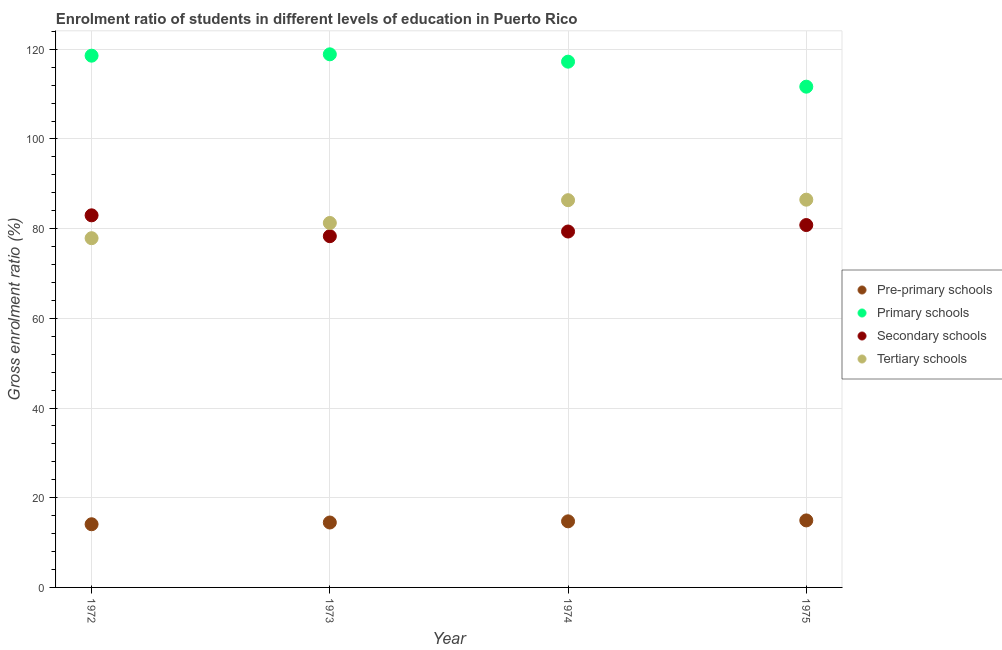How many different coloured dotlines are there?
Offer a terse response. 4. What is the gross enrolment ratio in tertiary schools in 1975?
Keep it short and to the point. 86.46. Across all years, what is the maximum gross enrolment ratio in secondary schools?
Offer a terse response. 82.97. Across all years, what is the minimum gross enrolment ratio in tertiary schools?
Make the answer very short. 77.87. In which year was the gross enrolment ratio in primary schools minimum?
Keep it short and to the point. 1975. What is the total gross enrolment ratio in pre-primary schools in the graph?
Ensure brevity in your answer.  58.24. What is the difference between the gross enrolment ratio in pre-primary schools in 1973 and that in 1975?
Provide a short and direct response. -0.46. What is the difference between the gross enrolment ratio in tertiary schools in 1972 and the gross enrolment ratio in secondary schools in 1973?
Your response must be concise. -0.45. What is the average gross enrolment ratio in tertiary schools per year?
Your response must be concise. 82.99. In the year 1975, what is the difference between the gross enrolment ratio in secondary schools and gross enrolment ratio in tertiary schools?
Ensure brevity in your answer.  -5.66. In how many years, is the gross enrolment ratio in tertiary schools greater than 84 %?
Offer a very short reply. 2. What is the ratio of the gross enrolment ratio in primary schools in 1973 to that in 1975?
Make the answer very short. 1.06. Is the gross enrolment ratio in secondary schools in 1973 less than that in 1974?
Your answer should be very brief. Yes. What is the difference between the highest and the second highest gross enrolment ratio in pre-primary schools?
Keep it short and to the point. 0.21. What is the difference between the highest and the lowest gross enrolment ratio in primary schools?
Keep it short and to the point. 7.21. Is it the case that in every year, the sum of the gross enrolment ratio in primary schools and gross enrolment ratio in tertiary schools is greater than the sum of gross enrolment ratio in pre-primary schools and gross enrolment ratio in secondary schools?
Make the answer very short. Yes. Is it the case that in every year, the sum of the gross enrolment ratio in pre-primary schools and gross enrolment ratio in primary schools is greater than the gross enrolment ratio in secondary schools?
Offer a terse response. Yes. Does the gross enrolment ratio in tertiary schools monotonically increase over the years?
Your answer should be very brief. Yes. Is the gross enrolment ratio in primary schools strictly less than the gross enrolment ratio in pre-primary schools over the years?
Provide a succinct answer. No. How many dotlines are there?
Make the answer very short. 4. How many years are there in the graph?
Your answer should be compact. 4. Are the values on the major ticks of Y-axis written in scientific E-notation?
Keep it short and to the point. No. Where does the legend appear in the graph?
Your answer should be compact. Center right. What is the title of the graph?
Give a very brief answer. Enrolment ratio of students in different levels of education in Puerto Rico. What is the label or title of the X-axis?
Give a very brief answer. Year. What is the label or title of the Y-axis?
Provide a succinct answer. Gross enrolment ratio (%). What is the Gross enrolment ratio (%) in Pre-primary schools in 1972?
Your answer should be very brief. 14.09. What is the Gross enrolment ratio (%) in Primary schools in 1972?
Your response must be concise. 118.57. What is the Gross enrolment ratio (%) in Secondary schools in 1972?
Offer a terse response. 82.97. What is the Gross enrolment ratio (%) of Tertiary schools in 1972?
Give a very brief answer. 77.87. What is the Gross enrolment ratio (%) in Pre-primary schools in 1973?
Keep it short and to the point. 14.48. What is the Gross enrolment ratio (%) of Primary schools in 1973?
Provide a short and direct response. 118.87. What is the Gross enrolment ratio (%) of Secondary schools in 1973?
Your answer should be very brief. 78.32. What is the Gross enrolment ratio (%) in Tertiary schools in 1973?
Provide a short and direct response. 81.26. What is the Gross enrolment ratio (%) of Pre-primary schools in 1974?
Provide a short and direct response. 14.74. What is the Gross enrolment ratio (%) in Primary schools in 1974?
Give a very brief answer. 117.23. What is the Gross enrolment ratio (%) in Secondary schools in 1974?
Offer a very short reply. 79.36. What is the Gross enrolment ratio (%) of Tertiary schools in 1974?
Ensure brevity in your answer.  86.35. What is the Gross enrolment ratio (%) of Pre-primary schools in 1975?
Your answer should be compact. 14.94. What is the Gross enrolment ratio (%) in Primary schools in 1975?
Offer a terse response. 111.66. What is the Gross enrolment ratio (%) in Secondary schools in 1975?
Keep it short and to the point. 80.8. What is the Gross enrolment ratio (%) in Tertiary schools in 1975?
Ensure brevity in your answer.  86.46. Across all years, what is the maximum Gross enrolment ratio (%) in Pre-primary schools?
Your response must be concise. 14.94. Across all years, what is the maximum Gross enrolment ratio (%) of Primary schools?
Give a very brief answer. 118.87. Across all years, what is the maximum Gross enrolment ratio (%) in Secondary schools?
Provide a short and direct response. 82.97. Across all years, what is the maximum Gross enrolment ratio (%) in Tertiary schools?
Your answer should be very brief. 86.46. Across all years, what is the minimum Gross enrolment ratio (%) in Pre-primary schools?
Provide a succinct answer. 14.09. Across all years, what is the minimum Gross enrolment ratio (%) in Primary schools?
Your answer should be very brief. 111.66. Across all years, what is the minimum Gross enrolment ratio (%) of Secondary schools?
Your answer should be compact. 78.32. Across all years, what is the minimum Gross enrolment ratio (%) in Tertiary schools?
Give a very brief answer. 77.87. What is the total Gross enrolment ratio (%) of Pre-primary schools in the graph?
Your answer should be compact. 58.24. What is the total Gross enrolment ratio (%) in Primary schools in the graph?
Make the answer very short. 466.33. What is the total Gross enrolment ratio (%) in Secondary schools in the graph?
Offer a very short reply. 321.45. What is the total Gross enrolment ratio (%) of Tertiary schools in the graph?
Ensure brevity in your answer.  331.94. What is the difference between the Gross enrolment ratio (%) of Pre-primary schools in 1972 and that in 1973?
Offer a very short reply. -0.39. What is the difference between the Gross enrolment ratio (%) of Primary schools in 1972 and that in 1973?
Your answer should be very brief. -0.3. What is the difference between the Gross enrolment ratio (%) in Secondary schools in 1972 and that in 1973?
Provide a succinct answer. 4.65. What is the difference between the Gross enrolment ratio (%) of Tertiary schools in 1972 and that in 1973?
Your answer should be compact. -3.39. What is the difference between the Gross enrolment ratio (%) in Pre-primary schools in 1972 and that in 1974?
Provide a succinct answer. -0.65. What is the difference between the Gross enrolment ratio (%) of Primary schools in 1972 and that in 1974?
Make the answer very short. 1.33. What is the difference between the Gross enrolment ratio (%) of Secondary schools in 1972 and that in 1974?
Offer a terse response. 3.61. What is the difference between the Gross enrolment ratio (%) in Tertiary schools in 1972 and that in 1974?
Give a very brief answer. -8.48. What is the difference between the Gross enrolment ratio (%) of Pre-primary schools in 1972 and that in 1975?
Offer a very short reply. -0.86. What is the difference between the Gross enrolment ratio (%) of Primary schools in 1972 and that in 1975?
Offer a terse response. 6.91. What is the difference between the Gross enrolment ratio (%) in Secondary schools in 1972 and that in 1975?
Your answer should be very brief. 2.17. What is the difference between the Gross enrolment ratio (%) of Tertiary schools in 1972 and that in 1975?
Offer a very short reply. -8.59. What is the difference between the Gross enrolment ratio (%) in Pre-primary schools in 1973 and that in 1974?
Your answer should be very brief. -0.26. What is the difference between the Gross enrolment ratio (%) in Primary schools in 1973 and that in 1974?
Offer a very short reply. 1.64. What is the difference between the Gross enrolment ratio (%) of Secondary schools in 1973 and that in 1974?
Your answer should be very brief. -1.04. What is the difference between the Gross enrolment ratio (%) in Tertiary schools in 1973 and that in 1974?
Give a very brief answer. -5.08. What is the difference between the Gross enrolment ratio (%) of Pre-primary schools in 1973 and that in 1975?
Make the answer very short. -0.46. What is the difference between the Gross enrolment ratio (%) in Primary schools in 1973 and that in 1975?
Ensure brevity in your answer.  7.21. What is the difference between the Gross enrolment ratio (%) in Secondary schools in 1973 and that in 1975?
Offer a very short reply. -2.48. What is the difference between the Gross enrolment ratio (%) in Tertiary schools in 1973 and that in 1975?
Your answer should be compact. -5.2. What is the difference between the Gross enrolment ratio (%) of Pre-primary schools in 1974 and that in 1975?
Make the answer very short. -0.21. What is the difference between the Gross enrolment ratio (%) of Primary schools in 1974 and that in 1975?
Your response must be concise. 5.58. What is the difference between the Gross enrolment ratio (%) of Secondary schools in 1974 and that in 1975?
Your answer should be compact. -1.44. What is the difference between the Gross enrolment ratio (%) of Tertiary schools in 1974 and that in 1975?
Make the answer very short. -0.11. What is the difference between the Gross enrolment ratio (%) of Pre-primary schools in 1972 and the Gross enrolment ratio (%) of Primary schools in 1973?
Make the answer very short. -104.78. What is the difference between the Gross enrolment ratio (%) of Pre-primary schools in 1972 and the Gross enrolment ratio (%) of Secondary schools in 1973?
Provide a succinct answer. -64.23. What is the difference between the Gross enrolment ratio (%) in Pre-primary schools in 1972 and the Gross enrolment ratio (%) in Tertiary schools in 1973?
Ensure brevity in your answer.  -67.18. What is the difference between the Gross enrolment ratio (%) of Primary schools in 1972 and the Gross enrolment ratio (%) of Secondary schools in 1973?
Your answer should be compact. 40.25. What is the difference between the Gross enrolment ratio (%) in Primary schools in 1972 and the Gross enrolment ratio (%) in Tertiary schools in 1973?
Provide a short and direct response. 37.3. What is the difference between the Gross enrolment ratio (%) in Secondary schools in 1972 and the Gross enrolment ratio (%) in Tertiary schools in 1973?
Keep it short and to the point. 1.71. What is the difference between the Gross enrolment ratio (%) in Pre-primary schools in 1972 and the Gross enrolment ratio (%) in Primary schools in 1974?
Keep it short and to the point. -103.15. What is the difference between the Gross enrolment ratio (%) of Pre-primary schools in 1972 and the Gross enrolment ratio (%) of Secondary schools in 1974?
Give a very brief answer. -65.28. What is the difference between the Gross enrolment ratio (%) in Pre-primary schools in 1972 and the Gross enrolment ratio (%) in Tertiary schools in 1974?
Give a very brief answer. -72.26. What is the difference between the Gross enrolment ratio (%) in Primary schools in 1972 and the Gross enrolment ratio (%) in Secondary schools in 1974?
Give a very brief answer. 39.21. What is the difference between the Gross enrolment ratio (%) in Primary schools in 1972 and the Gross enrolment ratio (%) in Tertiary schools in 1974?
Provide a short and direct response. 32.22. What is the difference between the Gross enrolment ratio (%) of Secondary schools in 1972 and the Gross enrolment ratio (%) of Tertiary schools in 1974?
Make the answer very short. -3.38. What is the difference between the Gross enrolment ratio (%) in Pre-primary schools in 1972 and the Gross enrolment ratio (%) in Primary schools in 1975?
Your response must be concise. -97.57. What is the difference between the Gross enrolment ratio (%) in Pre-primary schools in 1972 and the Gross enrolment ratio (%) in Secondary schools in 1975?
Ensure brevity in your answer.  -66.72. What is the difference between the Gross enrolment ratio (%) of Pre-primary schools in 1972 and the Gross enrolment ratio (%) of Tertiary schools in 1975?
Make the answer very short. -72.37. What is the difference between the Gross enrolment ratio (%) of Primary schools in 1972 and the Gross enrolment ratio (%) of Secondary schools in 1975?
Your answer should be compact. 37.77. What is the difference between the Gross enrolment ratio (%) in Primary schools in 1972 and the Gross enrolment ratio (%) in Tertiary schools in 1975?
Your answer should be compact. 32.11. What is the difference between the Gross enrolment ratio (%) in Secondary schools in 1972 and the Gross enrolment ratio (%) in Tertiary schools in 1975?
Give a very brief answer. -3.49. What is the difference between the Gross enrolment ratio (%) of Pre-primary schools in 1973 and the Gross enrolment ratio (%) of Primary schools in 1974?
Provide a succinct answer. -102.76. What is the difference between the Gross enrolment ratio (%) of Pre-primary schools in 1973 and the Gross enrolment ratio (%) of Secondary schools in 1974?
Make the answer very short. -64.88. What is the difference between the Gross enrolment ratio (%) in Pre-primary schools in 1973 and the Gross enrolment ratio (%) in Tertiary schools in 1974?
Your answer should be compact. -71.87. What is the difference between the Gross enrolment ratio (%) of Primary schools in 1973 and the Gross enrolment ratio (%) of Secondary schools in 1974?
Provide a succinct answer. 39.51. What is the difference between the Gross enrolment ratio (%) of Primary schools in 1973 and the Gross enrolment ratio (%) of Tertiary schools in 1974?
Provide a short and direct response. 32.52. What is the difference between the Gross enrolment ratio (%) in Secondary schools in 1973 and the Gross enrolment ratio (%) in Tertiary schools in 1974?
Offer a terse response. -8.03. What is the difference between the Gross enrolment ratio (%) in Pre-primary schools in 1973 and the Gross enrolment ratio (%) in Primary schools in 1975?
Provide a succinct answer. -97.18. What is the difference between the Gross enrolment ratio (%) of Pre-primary schools in 1973 and the Gross enrolment ratio (%) of Secondary schools in 1975?
Offer a terse response. -66.33. What is the difference between the Gross enrolment ratio (%) of Pre-primary schools in 1973 and the Gross enrolment ratio (%) of Tertiary schools in 1975?
Make the answer very short. -71.98. What is the difference between the Gross enrolment ratio (%) in Primary schools in 1973 and the Gross enrolment ratio (%) in Secondary schools in 1975?
Keep it short and to the point. 38.07. What is the difference between the Gross enrolment ratio (%) of Primary schools in 1973 and the Gross enrolment ratio (%) of Tertiary schools in 1975?
Your answer should be very brief. 32.41. What is the difference between the Gross enrolment ratio (%) in Secondary schools in 1973 and the Gross enrolment ratio (%) in Tertiary schools in 1975?
Provide a succinct answer. -8.14. What is the difference between the Gross enrolment ratio (%) in Pre-primary schools in 1974 and the Gross enrolment ratio (%) in Primary schools in 1975?
Provide a short and direct response. -96.92. What is the difference between the Gross enrolment ratio (%) of Pre-primary schools in 1974 and the Gross enrolment ratio (%) of Secondary schools in 1975?
Ensure brevity in your answer.  -66.07. What is the difference between the Gross enrolment ratio (%) of Pre-primary schools in 1974 and the Gross enrolment ratio (%) of Tertiary schools in 1975?
Ensure brevity in your answer.  -71.72. What is the difference between the Gross enrolment ratio (%) in Primary schools in 1974 and the Gross enrolment ratio (%) in Secondary schools in 1975?
Provide a short and direct response. 36.43. What is the difference between the Gross enrolment ratio (%) in Primary schools in 1974 and the Gross enrolment ratio (%) in Tertiary schools in 1975?
Make the answer very short. 30.77. What is the difference between the Gross enrolment ratio (%) in Secondary schools in 1974 and the Gross enrolment ratio (%) in Tertiary schools in 1975?
Offer a terse response. -7.1. What is the average Gross enrolment ratio (%) in Pre-primary schools per year?
Your answer should be compact. 14.56. What is the average Gross enrolment ratio (%) of Primary schools per year?
Ensure brevity in your answer.  116.58. What is the average Gross enrolment ratio (%) of Secondary schools per year?
Give a very brief answer. 80.36. What is the average Gross enrolment ratio (%) in Tertiary schools per year?
Ensure brevity in your answer.  82.99. In the year 1972, what is the difference between the Gross enrolment ratio (%) in Pre-primary schools and Gross enrolment ratio (%) in Primary schools?
Provide a short and direct response. -104.48. In the year 1972, what is the difference between the Gross enrolment ratio (%) in Pre-primary schools and Gross enrolment ratio (%) in Secondary schools?
Your response must be concise. -68.88. In the year 1972, what is the difference between the Gross enrolment ratio (%) in Pre-primary schools and Gross enrolment ratio (%) in Tertiary schools?
Your response must be concise. -63.78. In the year 1972, what is the difference between the Gross enrolment ratio (%) of Primary schools and Gross enrolment ratio (%) of Secondary schools?
Your answer should be very brief. 35.6. In the year 1972, what is the difference between the Gross enrolment ratio (%) in Primary schools and Gross enrolment ratio (%) in Tertiary schools?
Provide a succinct answer. 40.7. In the year 1972, what is the difference between the Gross enrolment ratio (%) in Secondary schools and Gross enrolment ratio (%) in Tertiary schools?
Keep it short and to the point. 5.1. In the year 1973, what is the difference between the Gross enrolment ratio (%) in Pre-primary schools and Gross enrolment ratio (%) in Primary schools?
Ensure brevity in your answer.  -104.39. In the year 1973, what is the difference between the Gross enrolment ratio (%) in Pre-primary schools and Gross enrolment ratio (%) in Secondary schools?
Make the answer very short. -63.84. In the year 1973, what is the difference between the Gross enrolment ratio (%) in Pre-primary schools and Gross enrolment ratio (%) in Tertiary schools?
Your response must be concise. -66.79. In the year 1973, what is the difference between the Gross enrolment ratio (%) of Primary schools and Gross enrolment ratio (%) of Secondary schools?
Your answer should be compact. 40.55. In the year 1973, what is the difference between the Gross enrolment ratio (%) of Primary schools and Gross enrolment ratio (%) of Tertiary schools?
Make the answer very short. 37.61. In the year 1973, what is the difference between the Gross enrolment ratio (%) in Secondary schools and Gross enrolment ratio (%) in Tertiary schools?
Your answer should be compact. -2.94. In the year 1974, what is the difference between the Gross enrolment ratio (%) of Pre-primary schools and Gross enrolment ratio (%) of Primary schools?
Make the answer very short. -102.5. In the year 1974, what is the difference between the Gross enrolment ratio (%) of Pre-primary schools and Gross enrolment ratio (%) of Secondary schools?
Keep it short and to the point. -64.63. In the year 1974, what is the difference between the Gross enrolment ratio (%) of Pre-primary schools and Gross enrolment ratio (%) of Tertiary schools?
Your response must be concise. -71.61. In the year 1974, what is the difference between the Gross enrolment ratio (%) in Primary schools and Gross enrolment ratio (%) in Secondary schools?
Your response must be concise. 37.87. In the year 1974, what is the difference between the Gross enrolment ratio (%) in Primary schools and Gross enrolment ratio (%) in Tertiary schools?
Give a very brief answer. 30.89. In the year 1974, what is the difference between the Gross enrolment ratio (%) in Secondary schools and Gross enrolment ratio (%) in Tertiary schools?
Offer a terse response. -6.98. In the year 1975, what is the difference between the Gross enrolment ratio (%) of Pre-primary schools and Gross enrolment ratio (%) of Primary schools?
Provide a short and direct response. -96.72. In the year 1975, what is the difference between the Gross enrolment ratio (%) of Pre-primary schools and Gross enrolment ratio (%) of Secondary schools?
Provide a succinct answer. -65.86. In the year 1975, what is the difference between the Gross enrolment ratio (%) in Pre-primary schools and Gross enrolment ratio (%) in Tertiary schools?
Offer a very short reply. -71.52. In the year 1975, what is the difference between the Gross enrolment ratio (%) of Primary schools and Gross enrolment ratio (%) of Secondary schools?
Make the answer very short. 30.85. In the year 1975, what is the difference between the Gross enrolment ratio (%) of Primary schools and Gross enrolment ratio (%) of Tertiary schools?
Your answer should be very brief. 25.2. In the year 1975, what is the difference between the Gross enrolment ratio (%) in Secondary schools and Gross enrolment ratio (%) in Tertiary schools?
Give a very brief answer. -5.66. What is the ratio of the Gross enrolment ratio (%) of Pre-primary schools in 1972 to that in 1973?
Keep it short and to the point. 0.97. What is the ratio of the Gross enrolment ratio (%) in Secondary schools in 1972 to that in 1973?
Provide a short and direct response. 1.06. What is the ratio of the Gross enrolment ratio (%) in Tertiary schools in 1972 to that in 1973?
Make the answer very short. 0.96. What is the ratio of the Gross enrolment ratio (%) of Pre-primary schools in 1972 to that in 1974?
Provide a succinct answer. 0.96. What is the ratio of the Gross enrolment ratio (%) of Primary schools in 1972 to that in 1974?
Ensure brevity in your answer.  1.01. What is the ratio of the Gross enrolment ratio (%) of Secondary schools in 1972 to that in 1974?
Make the answer very short. 1.05. What is the ratio of the Gross enrolment ratio (%) of Tertiary schools in 1972 to that in 1974?
Your answer should be very brief. 0.9. What is the ratio of the Gross enrolment ratio (%) of Pre-primary schools in 1972 to that in 1975?
Your answer should be very brief. 0.94. What is the ratio of the Gross enrolment ratio (%) of Primary schools in 1972 to that in 1975?
Provide a short and direct response. 1.06. What is the ratio of the Gross enrolment ratio (%) in Secondary schools in 1972 to that in 1975?
Keep it short and to the point. 1.03. What is the ratio of the Gross enrolment ratio (%) in Tertiary schools in 1972 to that in 1975?
Give a very brief answer. 0.9. What is the ratio of the Gross enrolment ratio (%) in Pre-primary schools in 1973 to that in 1974?
Give a very brief answer. 0.98. What is the ratio of the Gross enrolment ratio (%) of Secondary schools in 1973 to that in 1974?
Your response must be concise. 0.99. What is the ratio of the Gross enrolment ratio (%) of Tertiary schools in 1973 to that in 1974?
Give a very brief answer. 0.94. What is the ratio of the Gross enrolment ratio (%) of Pre-primary schools in 1973 to that in 1975?
Offer a very short reply. 0.97. What is the ratio of the Gross enrolment ratio (%) in Primary schools in 1973 to that in 1975?
Provide a short and direct response. 1.06. What is the ratio of the Gross enrolment ratio (%) of Secondary schools in 1973 to that in 1975?
Your answer should be compact. 0.97. What is the ratio of the Gross enrolment ratio (%) of Tertiary schools in 1973 to that in 1975?
Provide a succinct answer. 0.94. What is the ratio of the Gross enrolment ratio (%) of Pre-primary schools in 1974 to that in 1975?
Ensure brevity in your answer.  0.99. What is the ratio of the Gross enrolment ratio (%) in Primary schools in 1974 to that in 1975?
Offer a very short reply. 1.05. What is the ratio of the Gross enrolment ratio (%) in Secondary schools in 1974 to that in 1975?
Provide a short and direct response. 0.98. What is the difference between the highest and the second highest Gross enrolment ratio (%) in Pre-primary schools?
Offer a terse response. 0.21. What is the difference between the highest and the second highest Gross enrolment ratio (%) in Primary schools?
Offer a very short reply. 0.3. What is the difference between the highest and the second highest Gross enrolment ratio (%) of Secondary schools?
Offer a terse response. 2.17. What is the difference between the highest and the second highest Gross enrolment ratio (%) of Tertiary schools?
Your answer should be very brief. 0.11. What is the difference between the highest and the lowest Gross enrolment ratio (%) in Pre-primary schools?
Keep it short and to the point. 0.86. What is the difference between the highest and the lowest Gross enrolment ratio (%) of Primary schools?
Ensure brevity in your answer.  7.21. What is the difference between the highest and the lowest Gross enrolment ratio (%) of Secondary schools?
Your answer should be compact. 4.65. What is the difference between the highest and the lowest Gross enrolment ratio (%) in Tertiary schools?
Give a very brief answer. 8.59. 